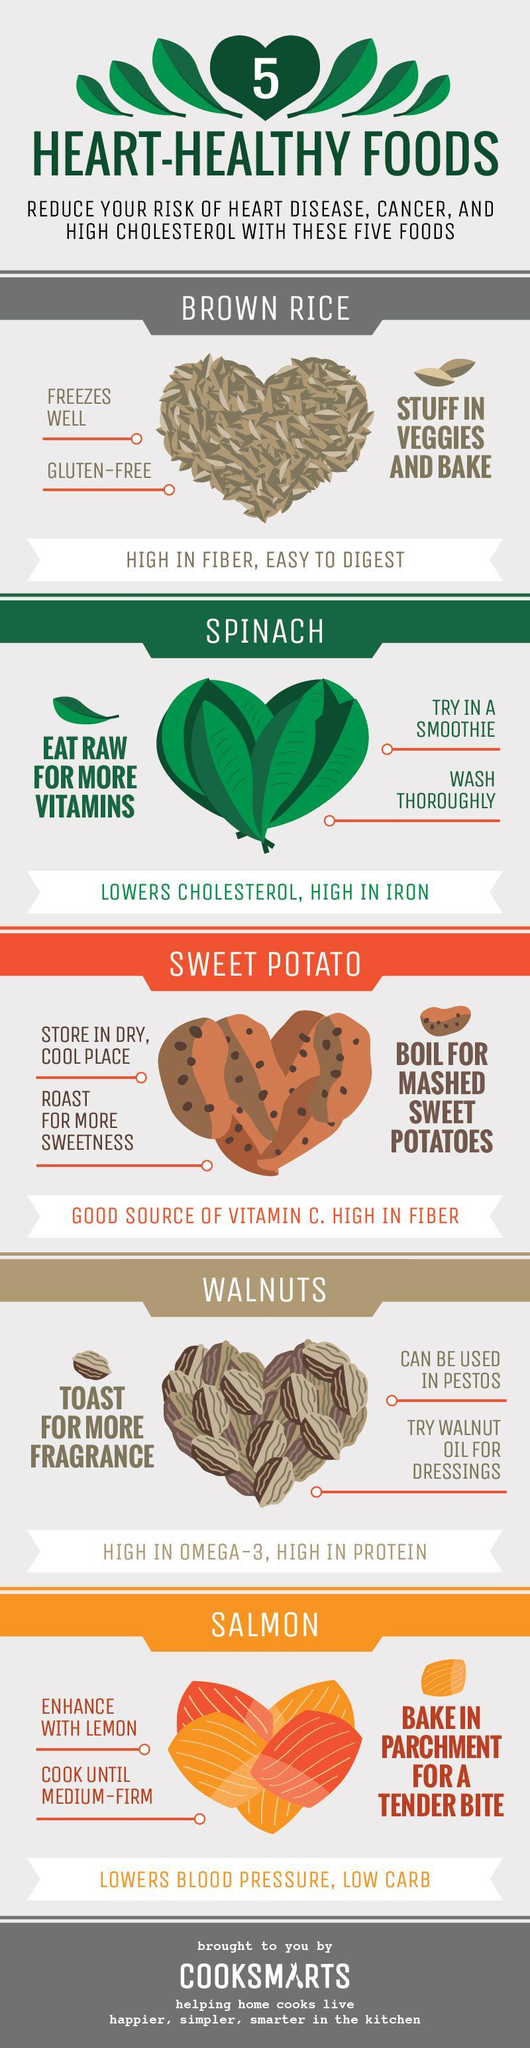What is the food item given in the second sub-heading?
Answer the question with a short phrase. spinach What is the food item given in the third sub-heading? sweet potato which three diseases can be reduced by having the food items in the given list? heart disease, cancer, high cholesterol What are the first two items in the list of heart-healthy foods? brown rice, spinach what are the foods that are rich in fiber? sweet potato, brown rice What is the food item given in the fourth sub-heading? walnuts What are the last three items in the list of heart-healthy foods? sweet potato, walnuts, salmon 